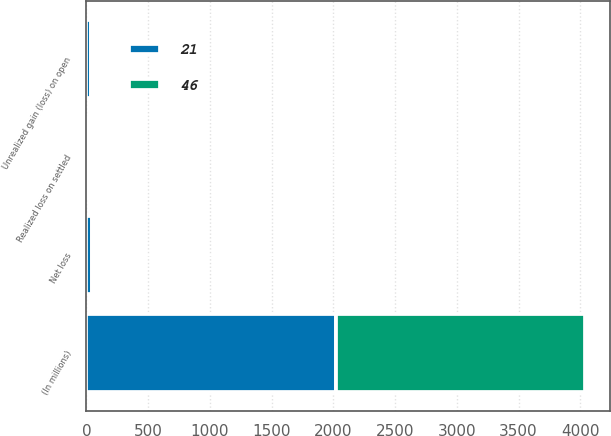Convert chart. <chart><loc_0><loc_0><loc_500><loc_500><stacked_bar_chart><ecel><fcel>(In millions)<fcel>Realized loss on settled<fcel>Unrealized gain (loss) on open<fcel>Net loss<nl><fcel>21<fcel>2018<fcel>11<fcel>35<fcel>46<nl><fcel>46<fcel>2017<fcel>27<fcel>6<fcel>21<nl></chart> 